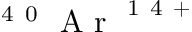<formula> <loc_0><loc_0><loc_500><loc_500>^ { 4 } 0 A r ^ { 1 4 + }</formula> 